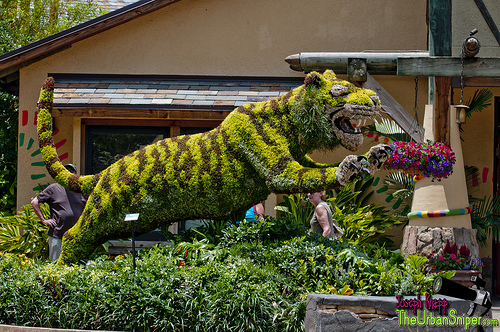<image>
Can you confirm if the tiger is under the building? No. The tiger is not positioned under the building. The vertical relationship between these objects is different. 